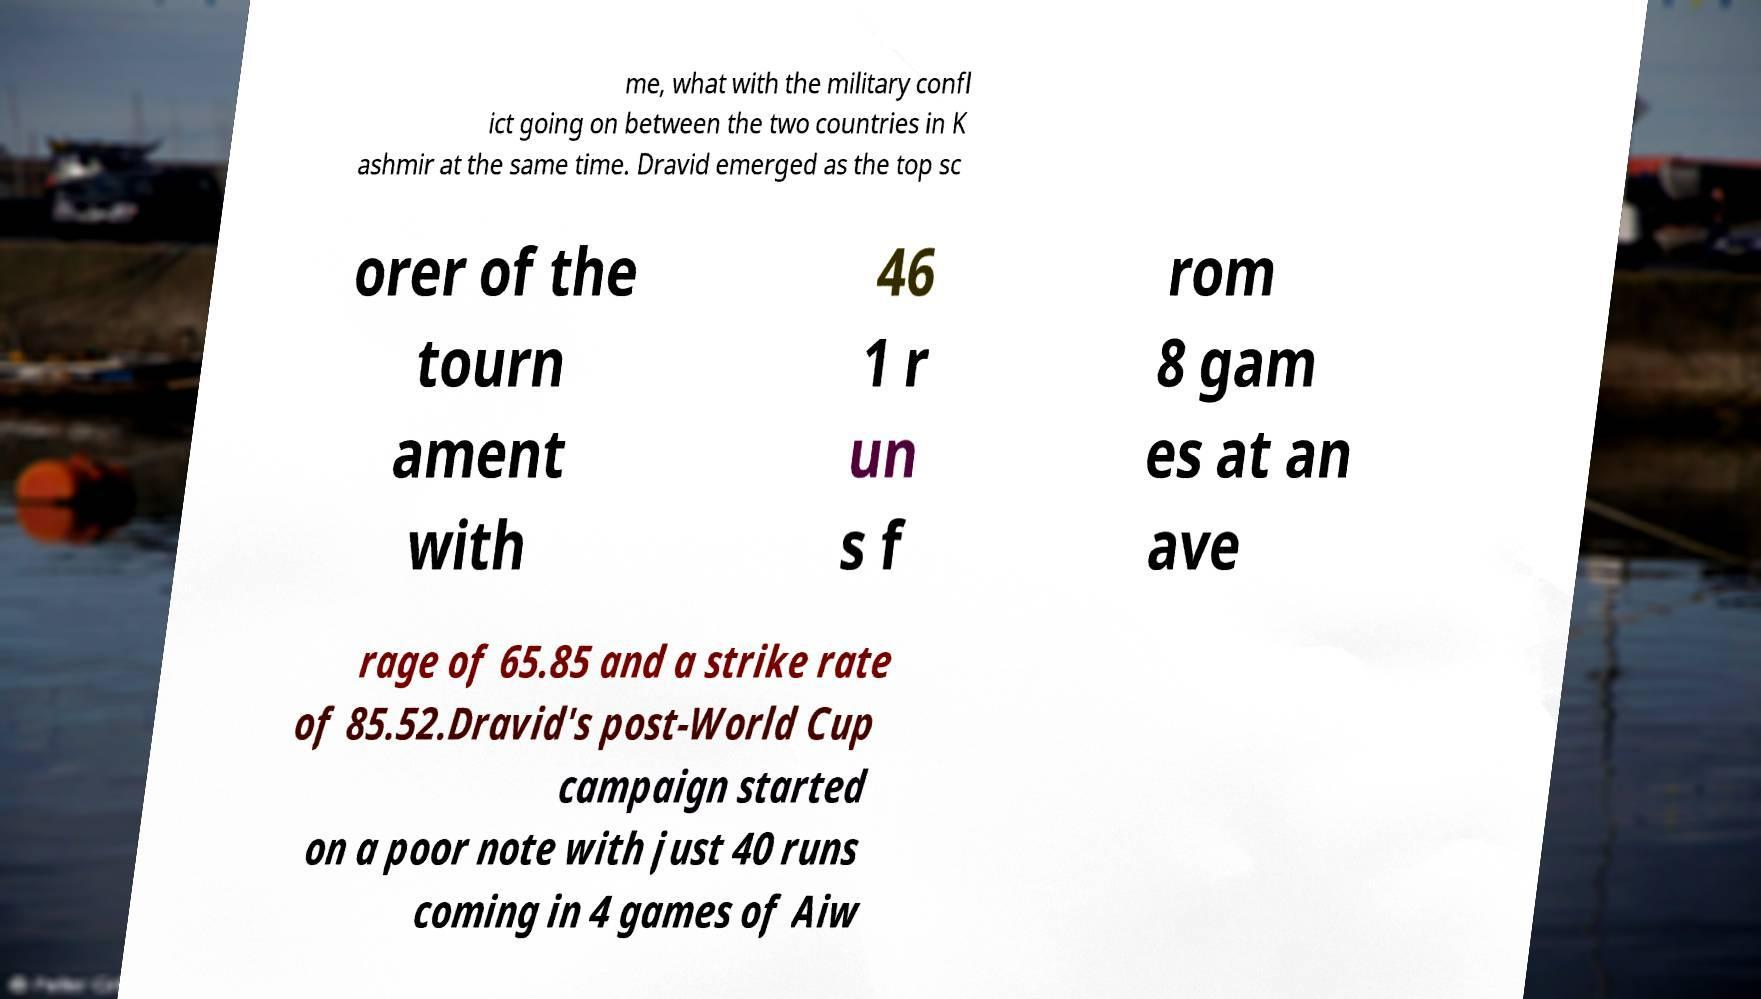Could you extract and type out the text from this image? me, what with the military confl ict going on between the two countries in K ashmir at the same time. Dravid emerged as the top sc orer of the tourn ament with 46 1 r un s f rom 8 gam es at an ave rage of 65.85 and a strike rate of 85.52.Dravid's post-World Cup campaign started on a poor note with just 40 runs coming in 4 games of Aiw 